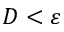<formula> <loc_0><loc_0><loc_500><loc_500>D < \varepsilon</formula> 